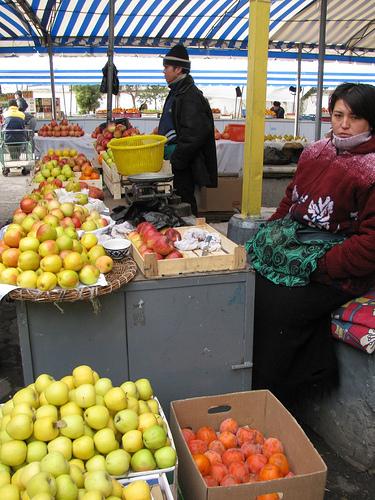Is the weather cold?
Quick response, please. Yes. What food area is this considered?
Quick response, please. Produce. Is the woman's hair tied back?
Write a very short answer. No. Why is the woman sit on a cushion?
Answer briefly. Comfort. 